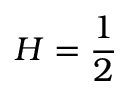<formula> <loc_0><loc_0><loc_500><loc_500>H = \frac { 1 } { 2 }</formula> 